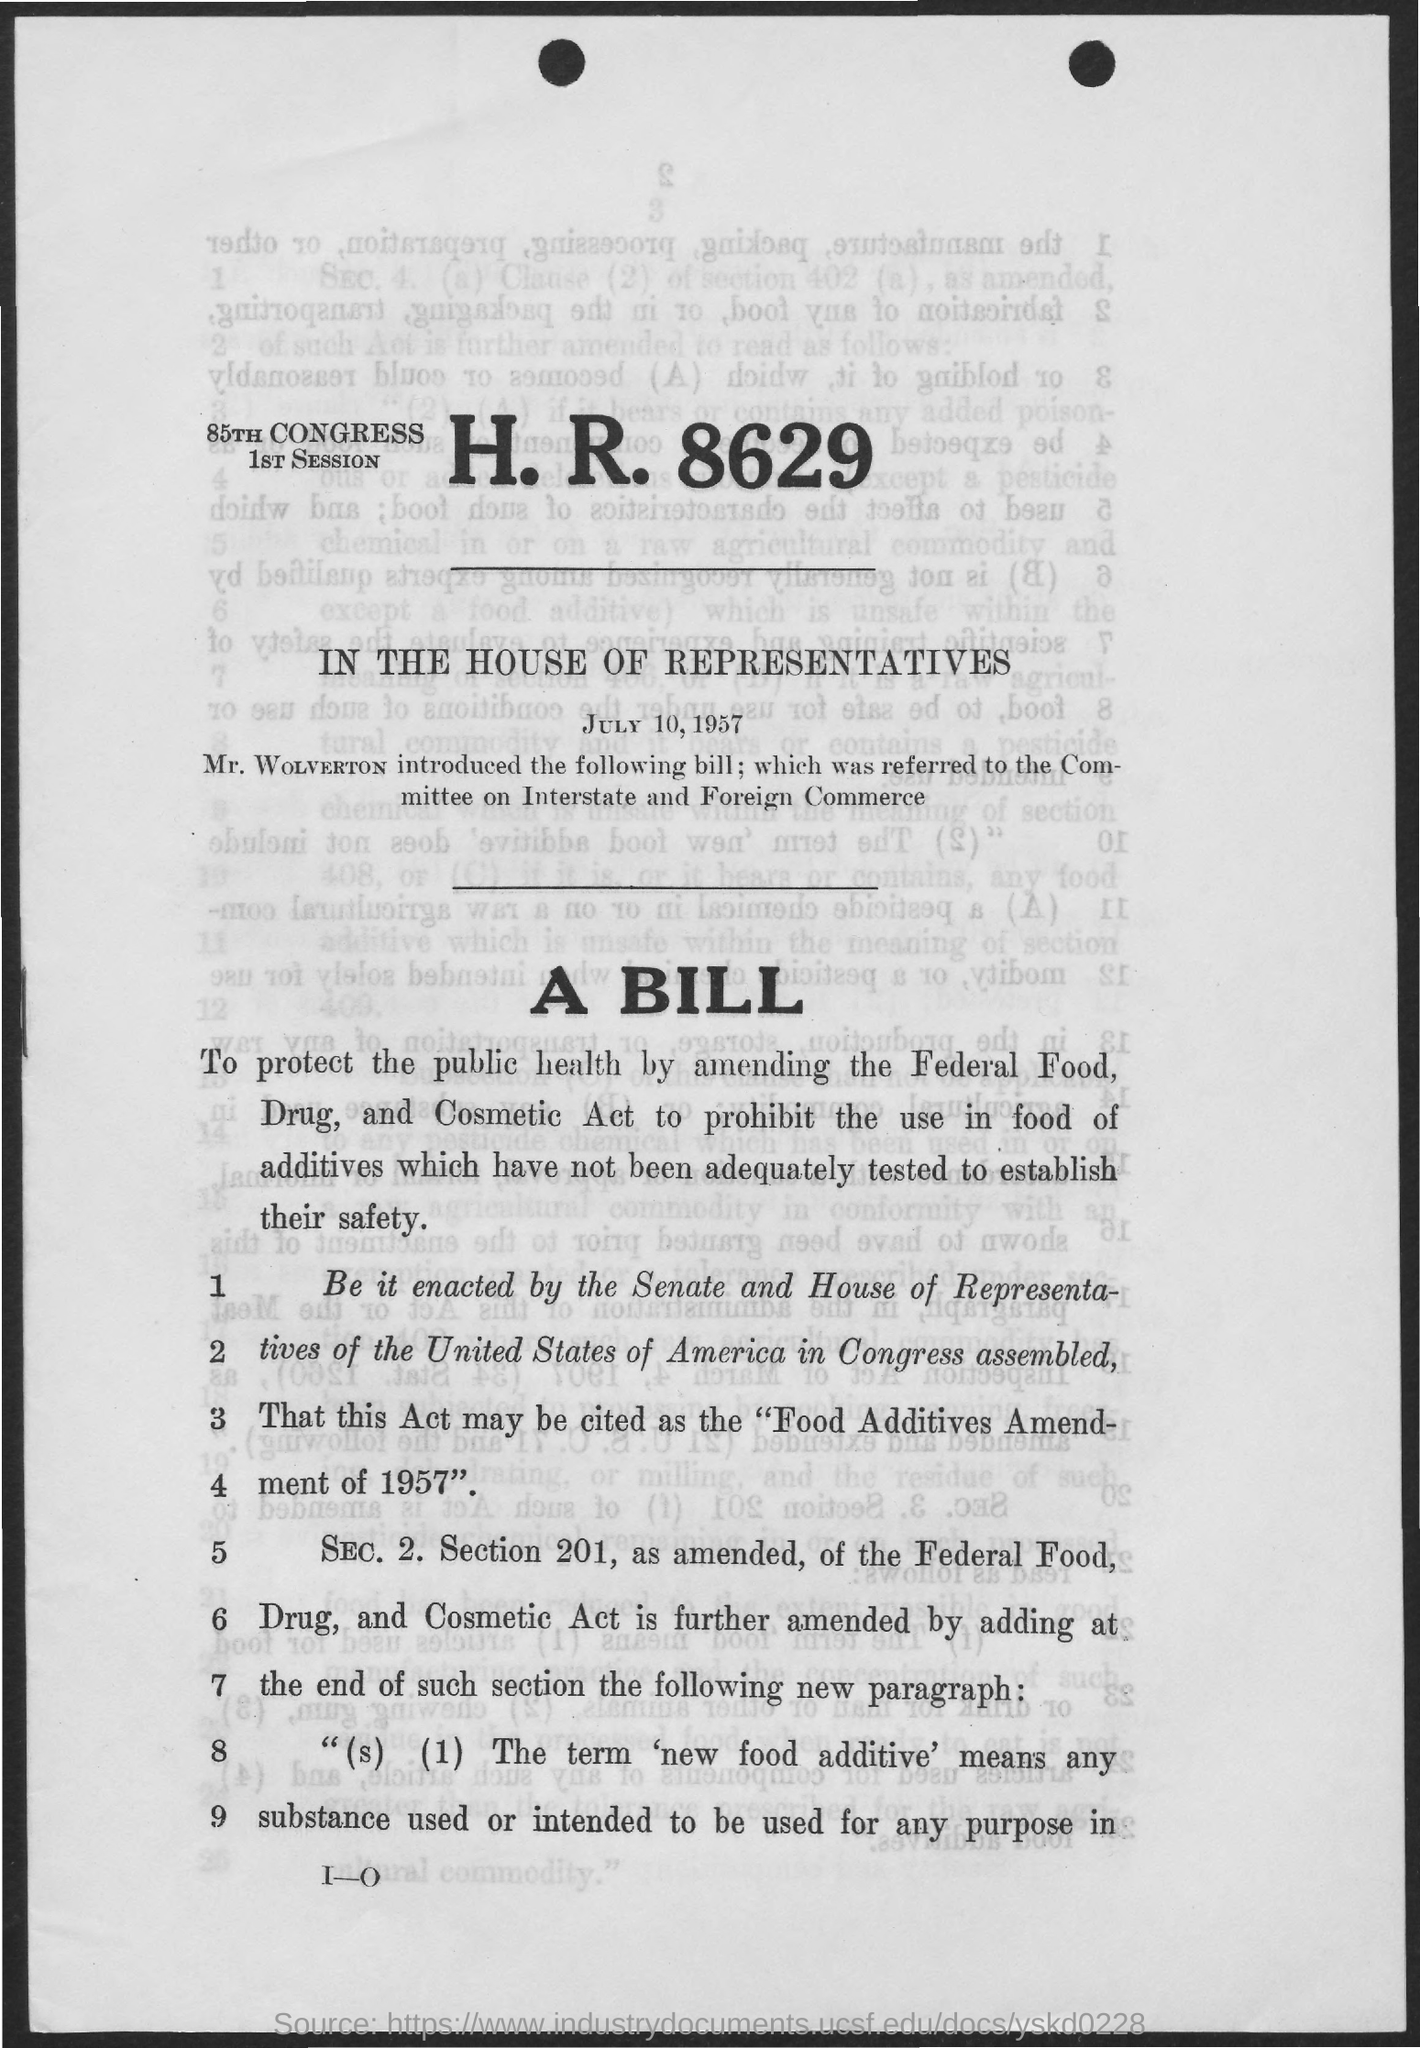Outline some significant characteristics in this image. The 85th Congress was held on July 10, 1957. The bill was introduced by Mr. WOLVERTON. The 85th Congress will be held in the House of Representatives. The bill was referred to the Committee on Interstate and Foreign Commerce for consideration. This act may be cited as the "Food Additives Amendment of 1957. 